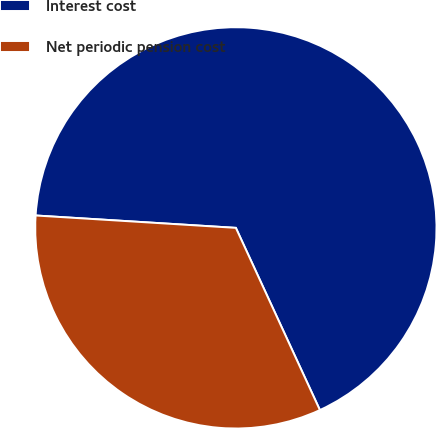<chart> <loc_0><loc_0><loc_500><loc_500><pie_chart><fcel>Interest cost<fcel>Net periodic pension cost<nl><fcel>67.14%<fcel>32.86%<nl></chart> 